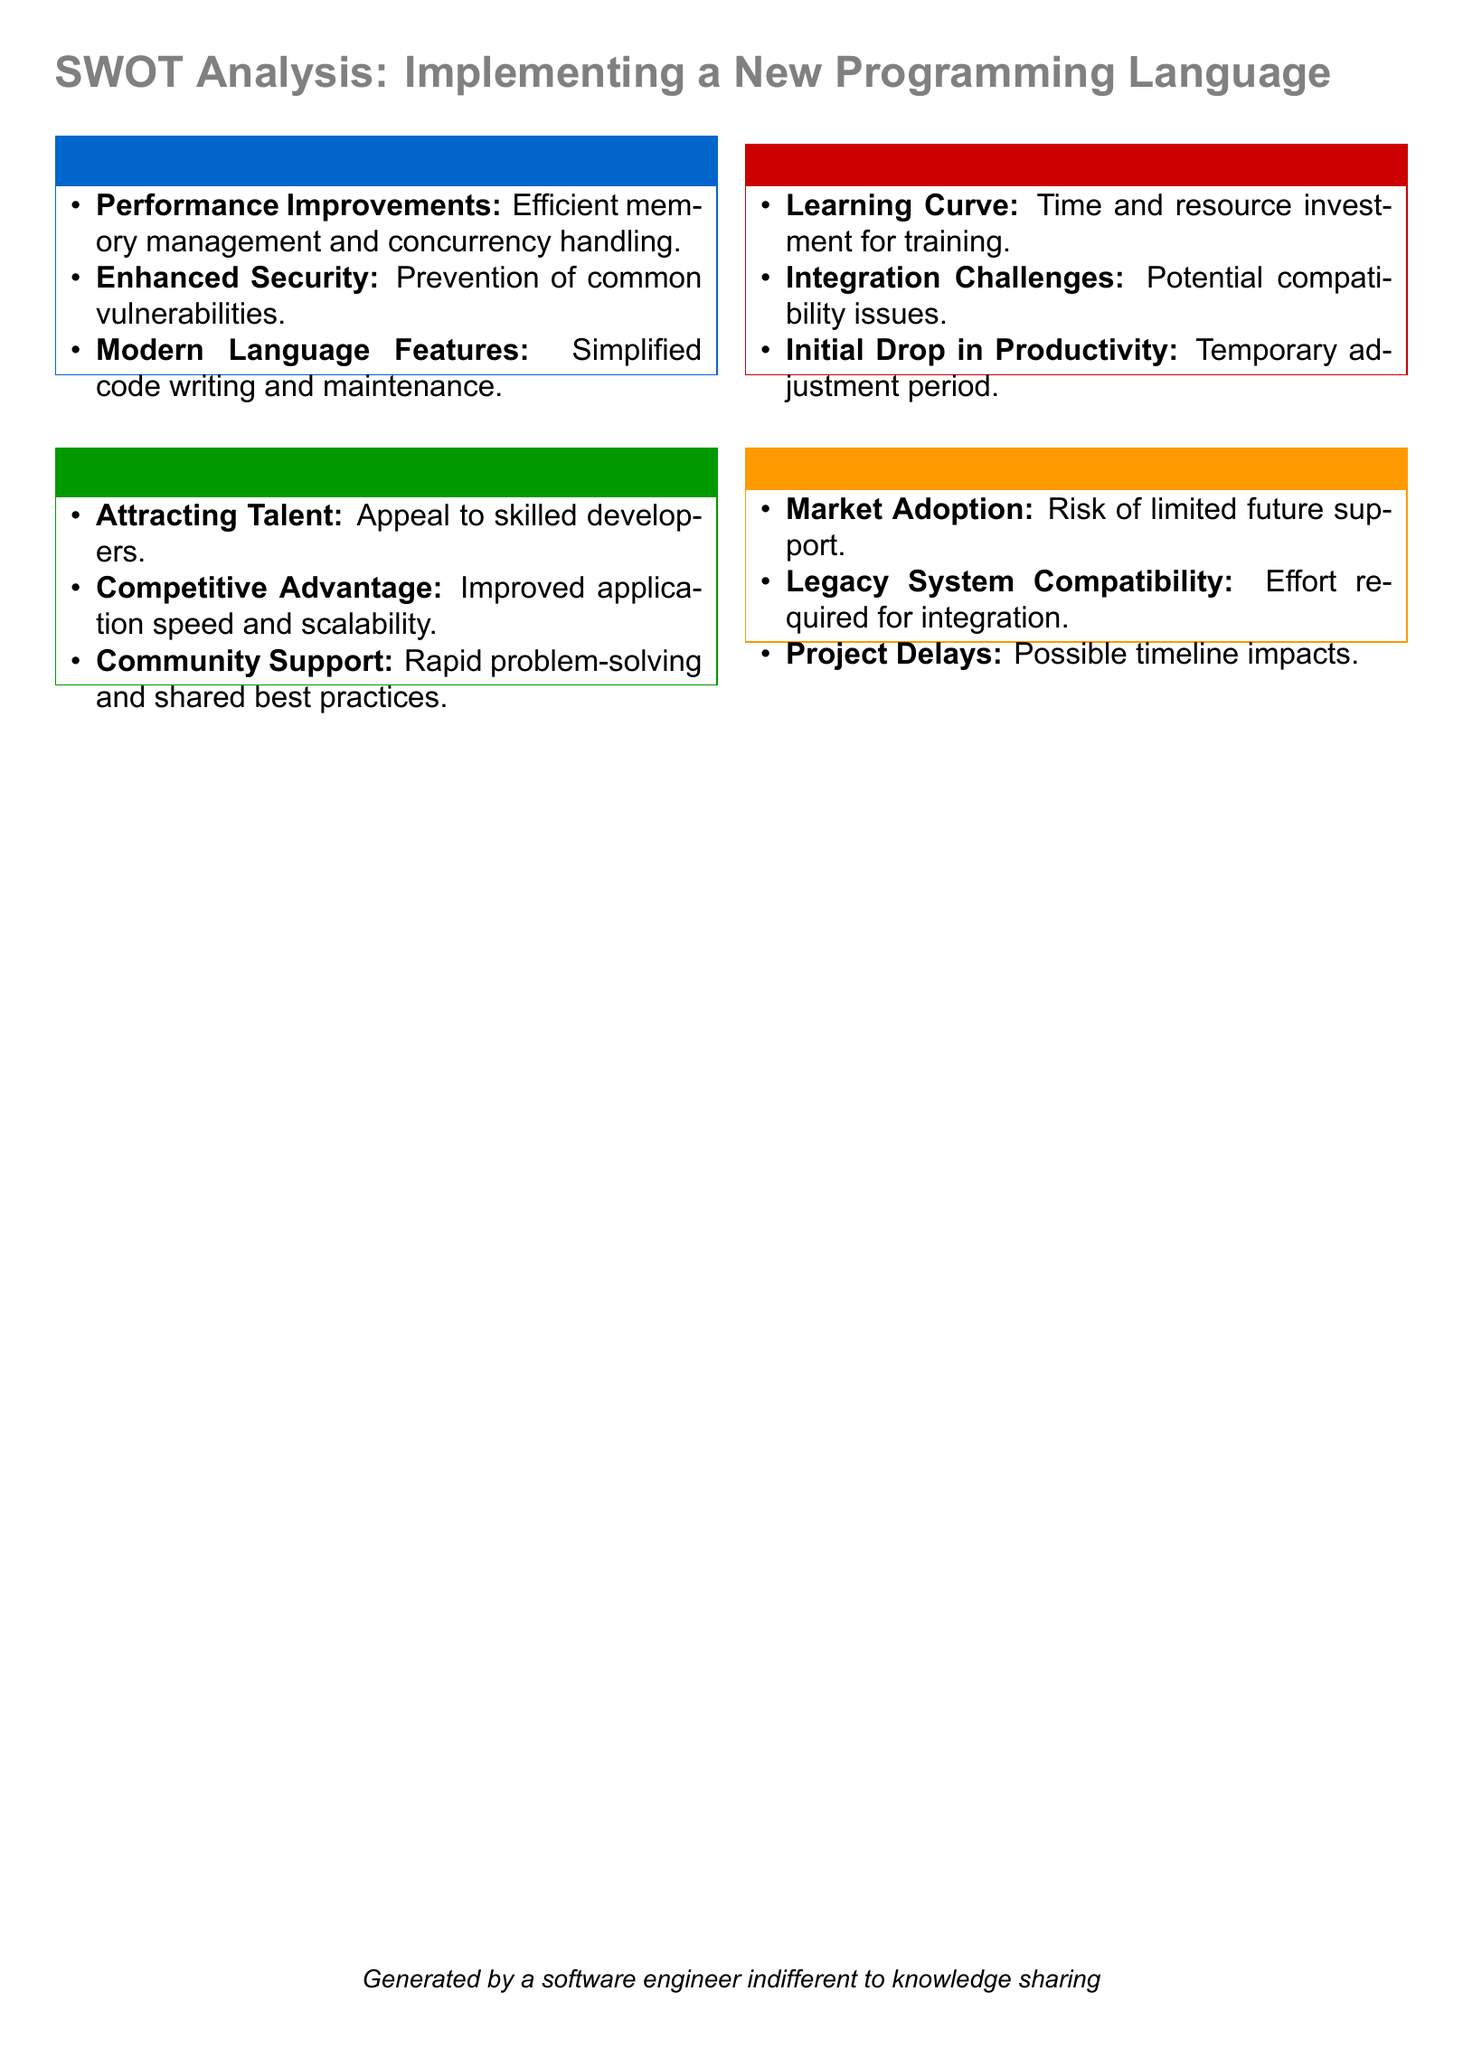What is one of the performance improvements mentioned? The performance improvements include efficient memory management and concurrency handling, which are highlighted under strengths.
Answer: Efficient memory management What is a potential opportunity according to the analysis? The analysis lists attracting talent as a potential opportunity in the opportunities section.
Answer: Attracting Talent What is a major weakness identified? One of the weaknesses mentioned is the learning curve, which is specified in the weaknesses section.
Answer: Learning Curve What is the color associated with threats? The color associated with threats is orange, as indicated by the threatcolor definition in the document.
Answer: Orange What might be a result of initial implementation according to the weaknesses? The document states that there could be an initial drop in productivity during the adjustment period, as listed under weaknesses.
Answer: Initial Drop in Productivity Which strength relates to security? Enhanced security is mentioned as a strength in the document, focusing on the prevention of common vulnerabilities.
Answer: Enhanced Security What is a threat regarding market conditions? A risk of limited future support is identified as a threat in the threats section.
Answer: Market Adoption How many key areas are covered in the SWOT analysis? The SWOT analysis covers four key areas: strengths, weaknesses, opportunities, and threats, which are all present in the document.
Answer: Four 